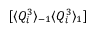Convert formula to latex. <formula><loc_0><loc_0><loc_500><loc_500>[ \langle Q _ { i } ^ { 3 } \rangle _ { - 1 } \langle Q _ { i } ^ { 3 } \rangle _ { 1 } ]</formula> 